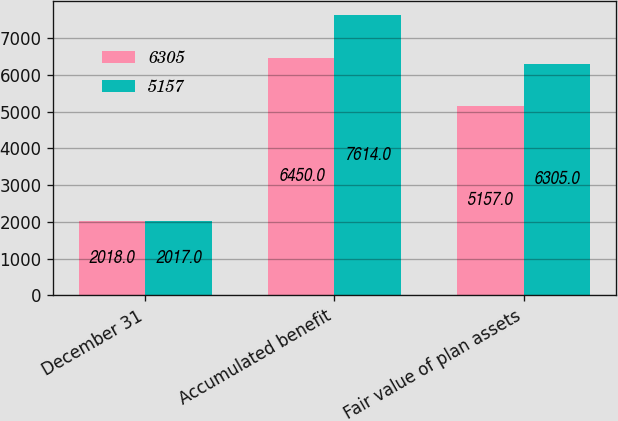<chart> <loc_0><loc_0><loc_500><loc_500><stacked_bar_chart><ecel><fcel>December 31<fcel>Accumulated benefit<fcel>Fair value of plan assets<nl><fcel>6305<fcel>2018<fcel>6450<fcel>5157<nl><fcel>5157<fcel>2017<fcel>7614<fcel>6305<nl></chart> 